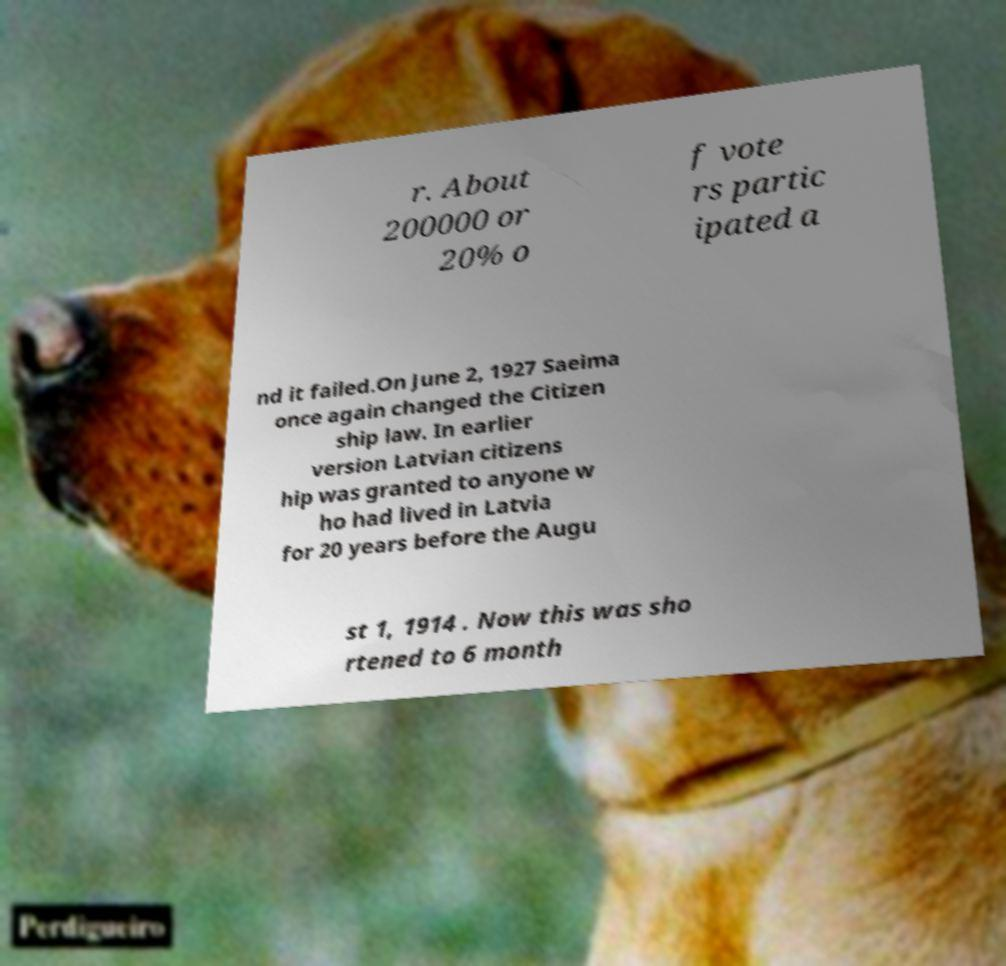Could you assist in decoding the text presented in this image and type it out clearly? r. About 200000 or 20% o f vote rs partic ipated a nd it failed.On June 2, 1927 Saeima once again changed the Citizen ship law. In earlier version Latvian citizens hip was granted to anyone w ho had lived in Latvia for 20 years before the Augu st 1, 1914 . Now this was sho rtened to 6 month 